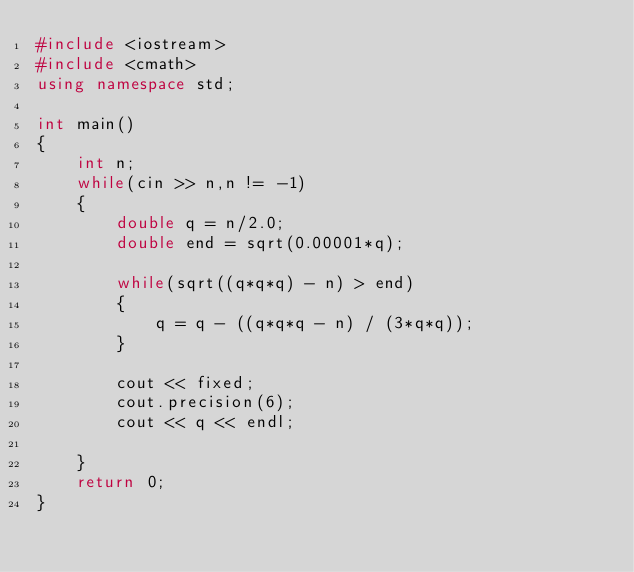Convert code to text. <code><loc_0><loc_0><loc_500><loc_500><_C++_>#include <iostream>
#include <cmath>
using namespace std;

int main()
{
	int n;
	while(cin >> n,n != -1)
	{
		double q = n/2.0;
		double end = sqrt(0.00001*q);

		while(sqrt((q*q*q) - n) > end)
		{
			q = q - ((q*q*q - n) / (3*q*q));
		}

		cout << fixed;
		cout.precision(6);
		cout << q << endl;
			
	}
	return 0;
}</code> 